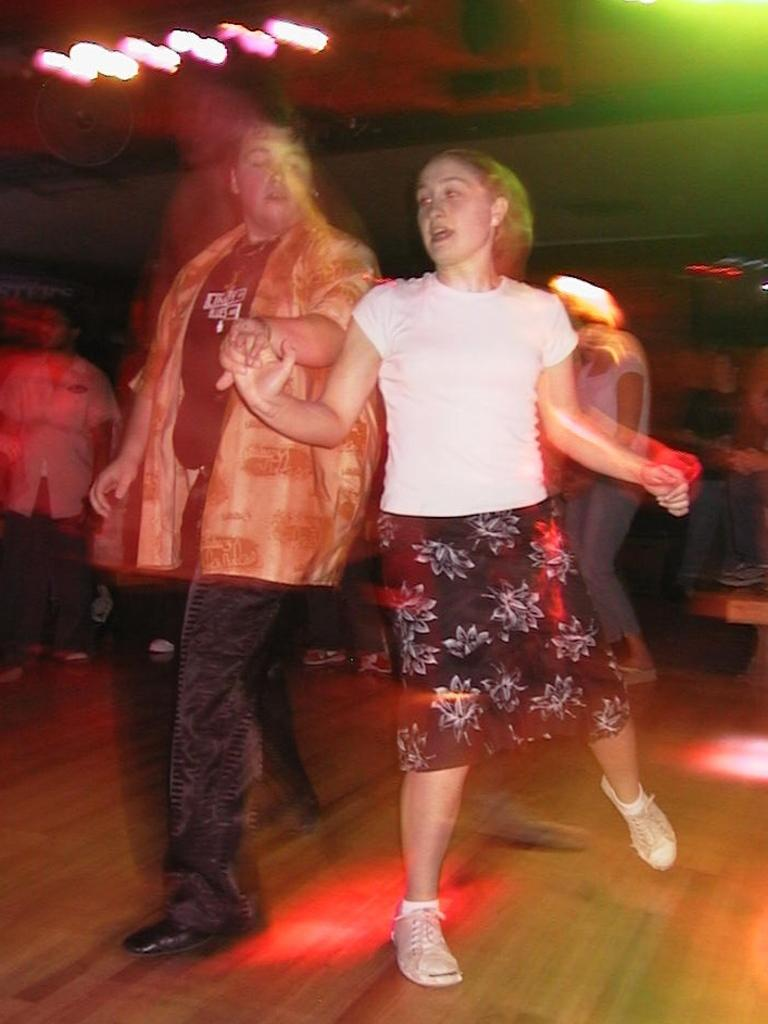Who is present in the image? There is a man and a woman in the image. What are the man and woman doing in the image? The man and woman appear to be dancing. Are there any other people in the image besides the man and woman? Yes, there are other people in the image. What can be seen in the background or surrounding the people in the image? There are lights in the image. What type of stamp can be seen on the side of the man in the image? There is no stamp visible on the man or any other person in the image. 